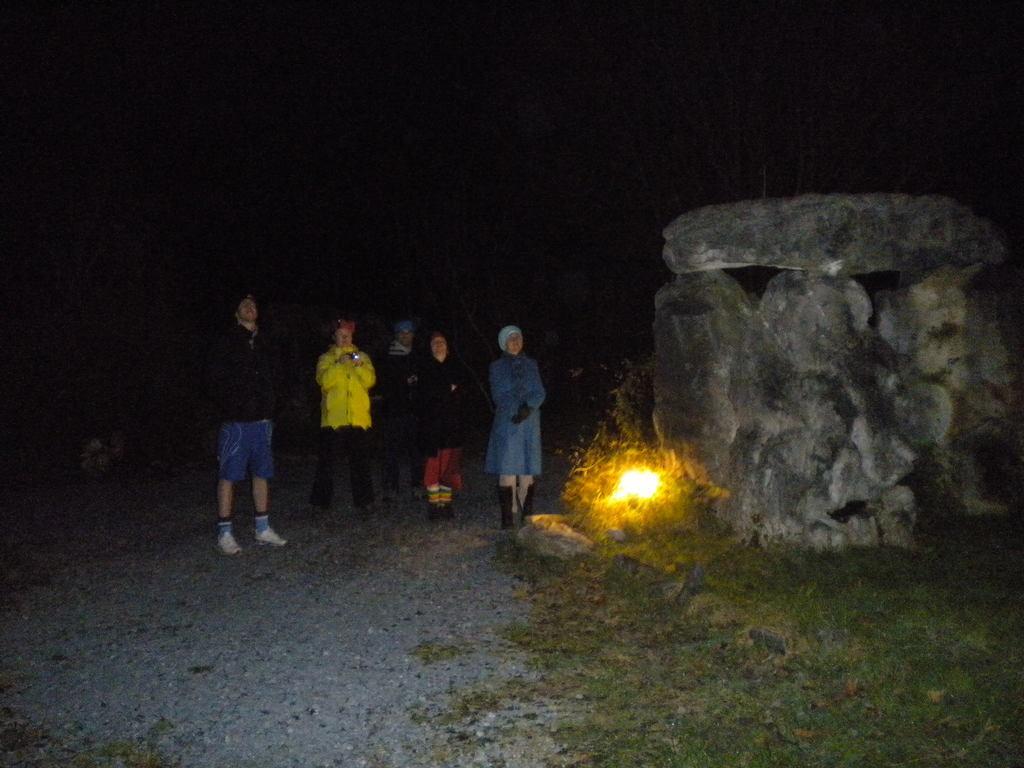In one or two sentences, can you explain what this image depicts? In this image I see few people and I see the green grass over here and I see the light over here and I see the rocks and it is in the background. 